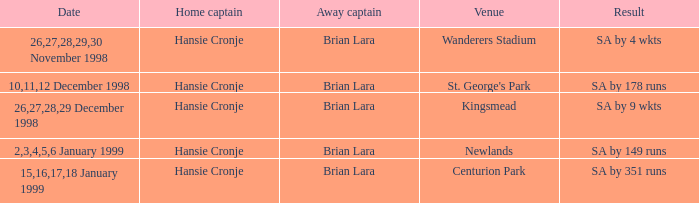Who is the away captain for Kingsmead? Brian Lara. 